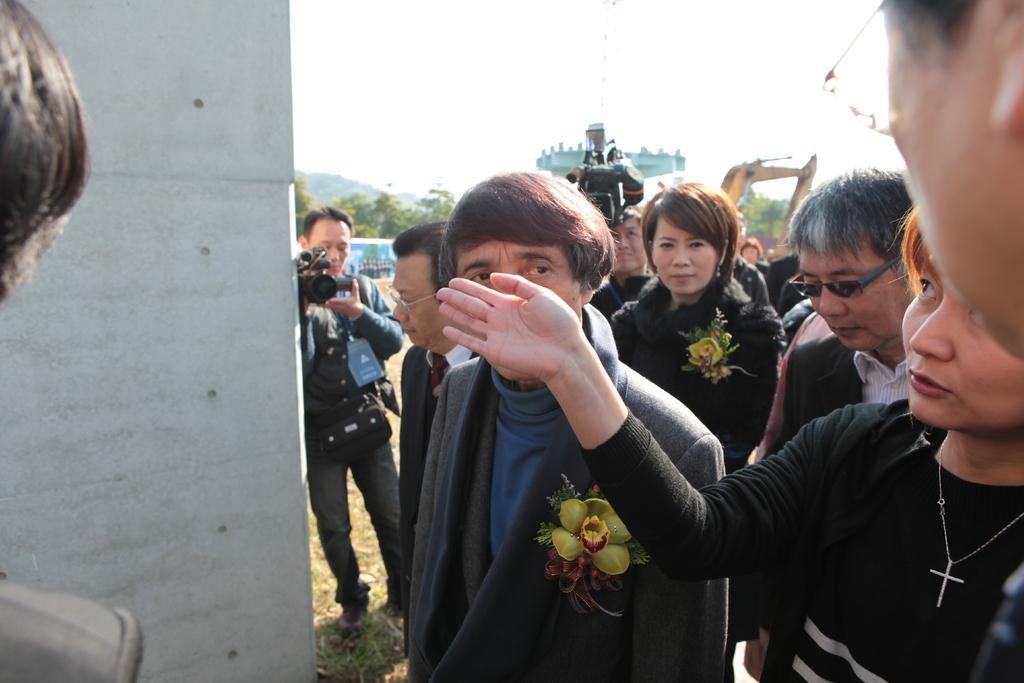What are the people in the image doing? There are people standing in the image, and some of them are holding cameras. What objects are the people holding in the image? The people holding cameras are holding cameras in the image. What can be seen in the background of the image? In the background of the image, there is a crane, trees, and mountains. Is there a passenger sitting on the lake in the image? There is no lake or passenger present in the image. 